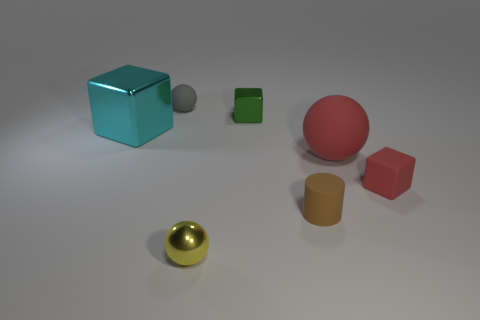What material is the tiny object that is the same color as the big matte sphere?
Provide a succinct answer. Rubber. The cylinder is what color?
Offer a terse response. Brown. Does the tiny brown cylinder have the same material as the big thing that is on the left side of the gray matte object?
Your answer should be compact. No. What number of shiny objects are both behind the shiny sphere and on the right side of the tiny gray object?
Give a very brief answer. 1. There is a yellow thing that is the same size as the gray matte thing; what shape is it?
Keep it short and to the point. Sphere. Is there a small cylinder that is on the left side of the matte thing to the left of the metal cube that is behind the cyan metal object?
Give a very brief answer. No. Is the color of the large metal block the same as the small ball behind the large cyan metallic cube?
Make the answer very short. No. How many other small cylinders have the same color as the small matte cylinder?
Provide a short and direct response. 0. What size is the matte sphere in front of the small shiny object right of the metal ball?
Ensure brevity in your answer.  Large. How many things are either matte spheres behind the large metal object or large matte blocks?
Keep it short and to the point. 1. 